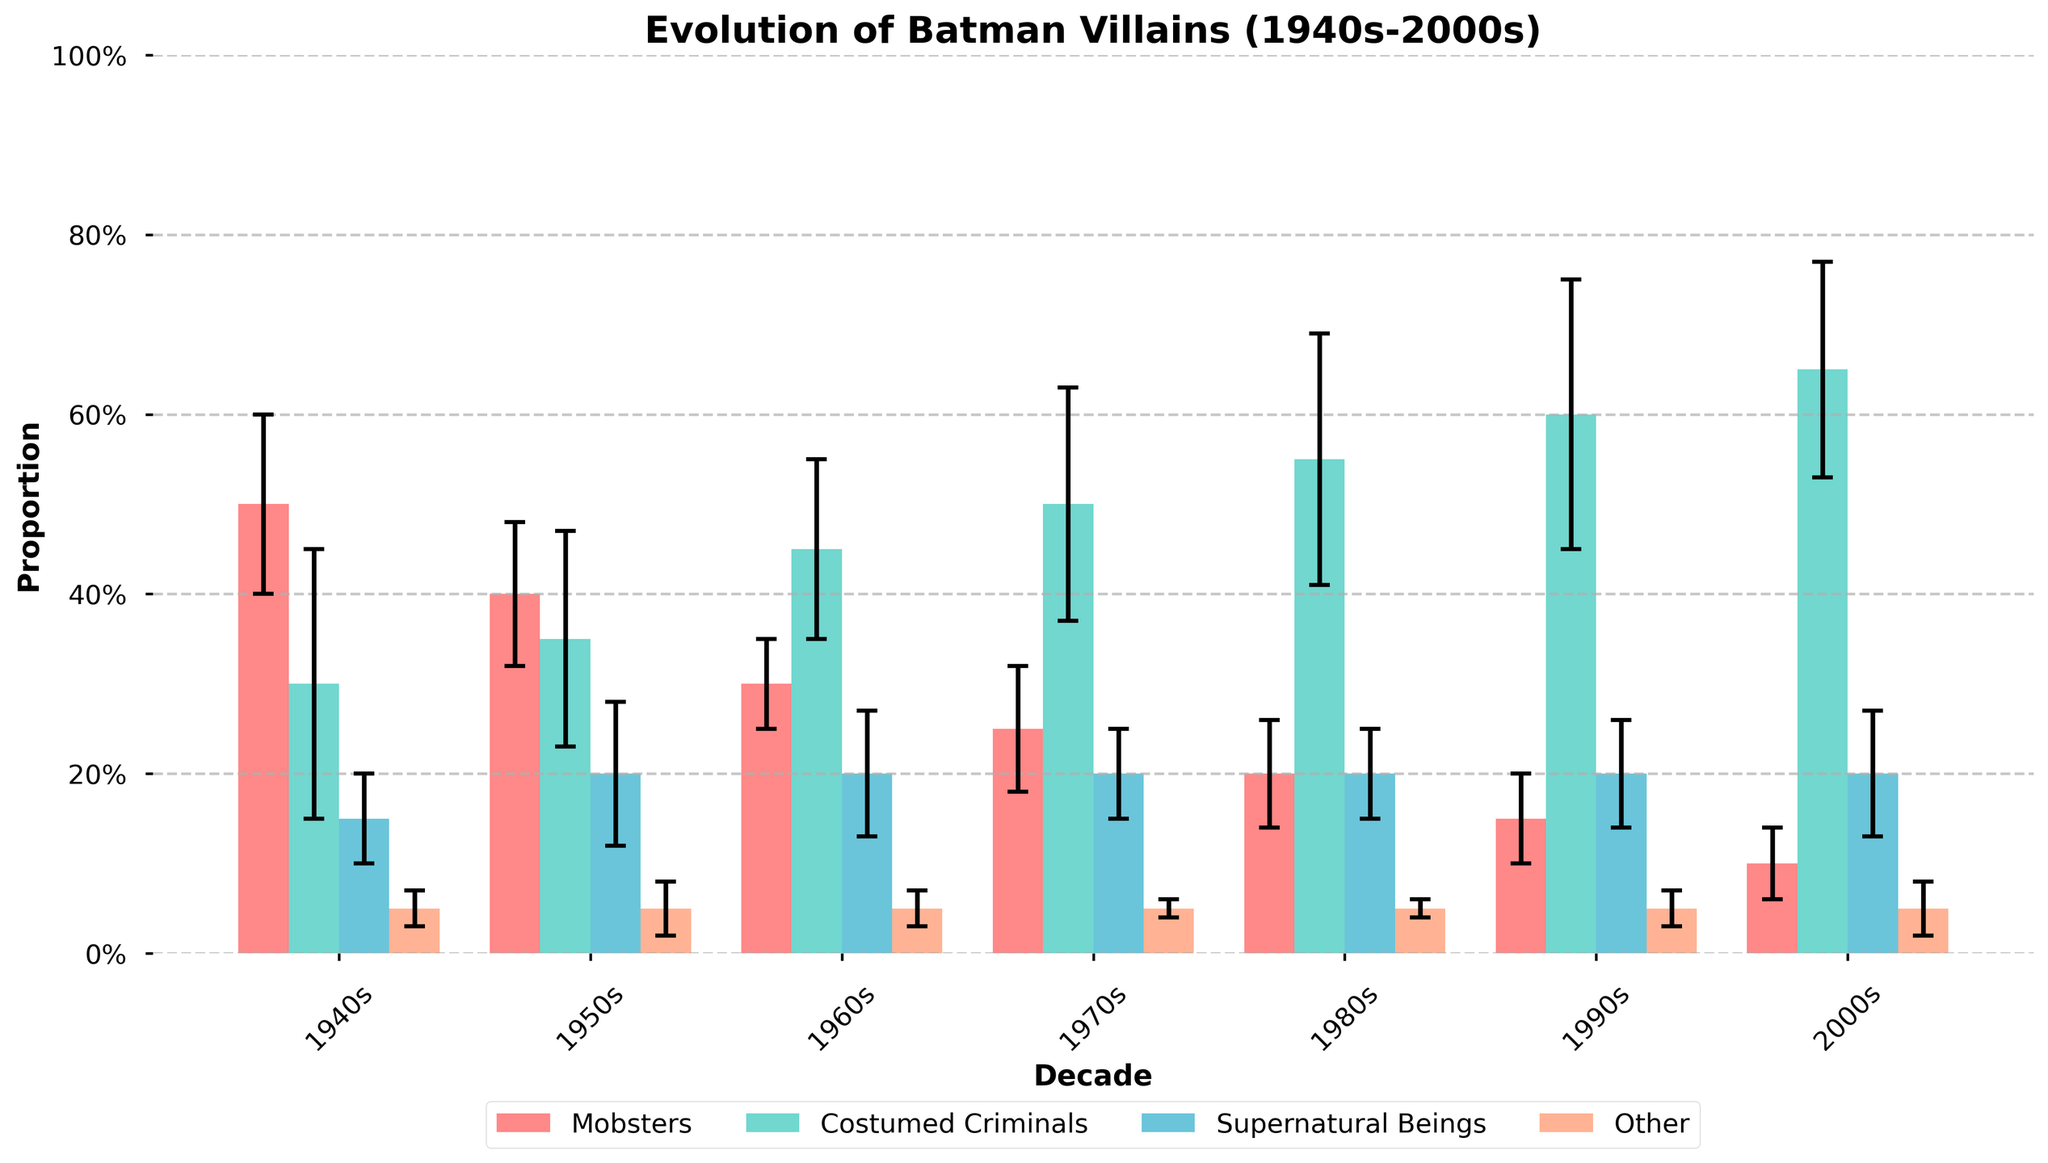What is the title of the chart? The title is prominently displayed at the top of the chart.
Answer: Evolution of Batman Villains (1940s-2000s) How many types of villains are shown in the chart? The chart legend shows four different colors, each representing a type of villain.
Answer: Four Which decade had the highest proportion of Mobsters? Observe the bars labeled "Mobsters" for each decade and identify the tallest one. The 1940s bar reaches 0.50 and is the tallest.
Answer: 1940s What is the general trend for Costumed Criminals over the decades? Track the height of each "Costumed Criminals" bar from 1940s to 2000s. The trend shows increasing height over time.
Answer: Increasing In which decade did Supernatural Beings have the smallest standard deviation? Check the error bars (caps on the top of each bar) for "Supernatural Beings" across decades. The 1940s has the shortest error bar.
Answer: 1940s What is the proportion of Mobsters in the 1990s? Reference the chart to find the "1990s" column and follow to the "Mobsters" bar, which reaches 0.15.
Answer: 0.15 Compare the proportion of Mobsters between the 1940s and the 2000s and calculate the difference. Trace back both bars, 0.50 for 1940s and 0.10 for 2000s. The difference is 0.50 - 0.10.
Answer: 0.40 Which type of villain has the most consistent proportion across the decades? Identify which type has similar bar heights across all decades. "Other" shows very uniform bars around 0.05.
Answer: Other Which decade has the highest average proportion of all villain types combined? Add the proportions for each type within each decade and compare. The 2000s sum up to the highest with an average of (0.10+0.65+0.20+0.05)/4.
Answer: 2000s What are the colors used to represent each type of villain? Refer to the legend that matches colors to villain types: Mobsters (#FF6B6B), Costumed Criminals (#4ECDC4), Supernatural Beings (#45B7D1), and Other (#FFA07A).
Answer: Red, Teal, Blue, Peach 